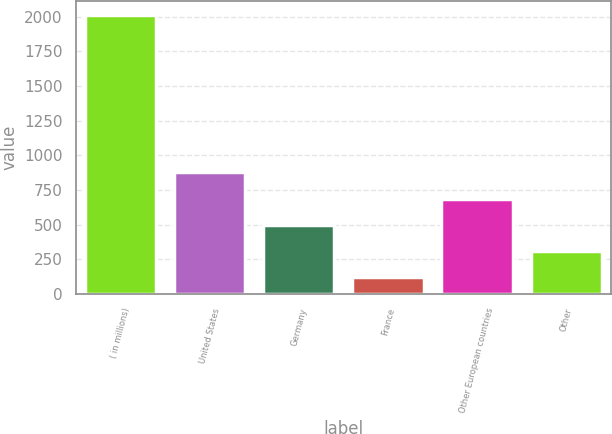Convert chart to OTSL. <chart><loc_0><loc_0><loc_500><loc_500><bar_chart><fcel>( in millions)<fcel>United States<fcel>Germany<fcel>France<fcel>Other European countries<fcel>Other<nl><fcel>2014<fcel>876.52<fcel>497.36<fcel>118.2<fcel>686.94<fcel>307.78<nl></chart> 